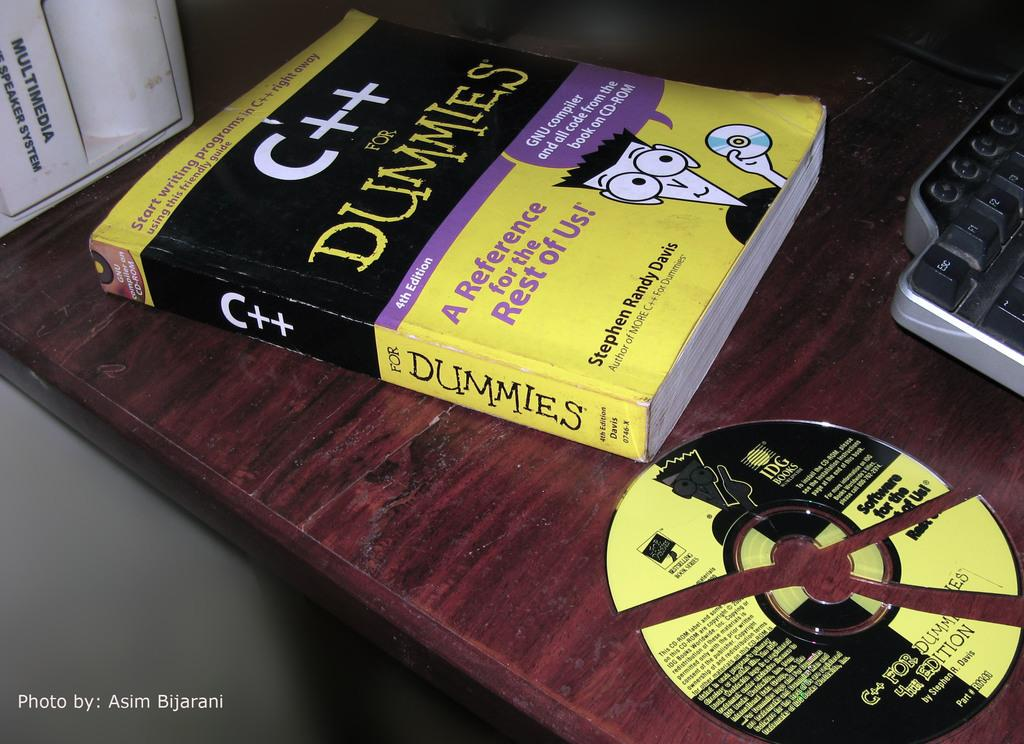What is one of the objects placed on the table in the image? There is a book in the image. What other object can be seen on the table? There is a cutter disk in the image. What is the third object placed on the table? There is a keyboard in the image. What type of scent can be detected from the book in the image? There is no mention of a scent in the image, and the book is not described as having a particular smell. How many seats are visible in the image? There is no mention of seats in the image; it only shows a table with objects on it. 